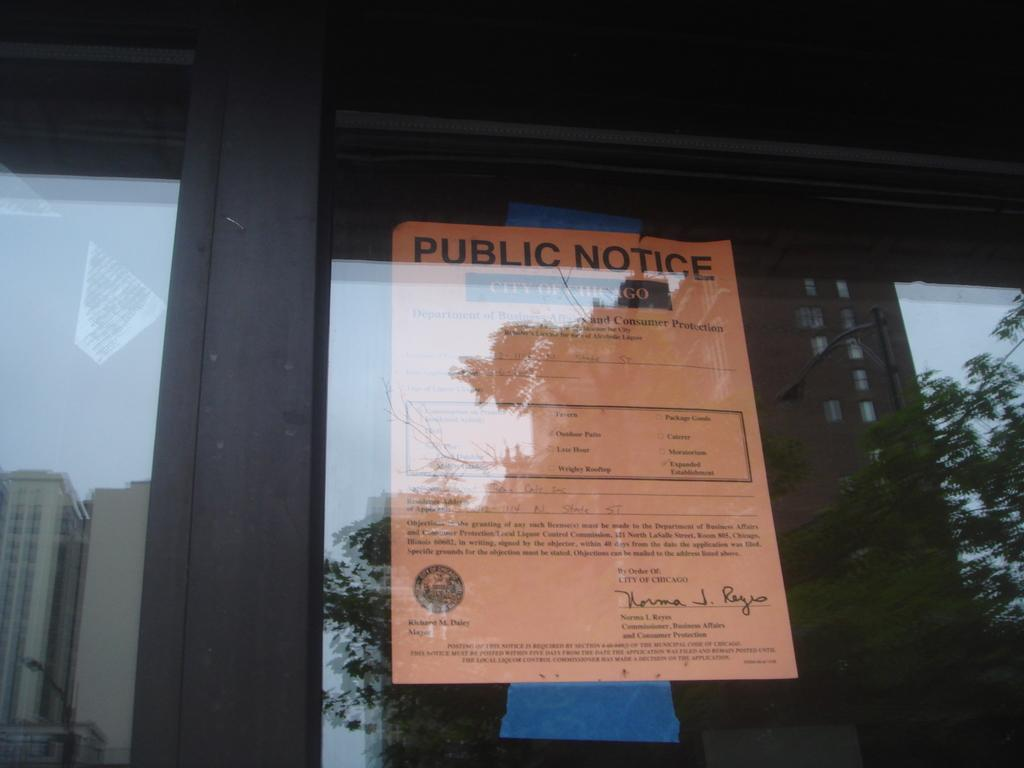What is attached to the transparent glass in the image? There is a paper stuck to a transparent glass in the image. What can be seen in the reflections on the transparent glass? There is a reflection of a building, trees, and the sky on the transparent glass. Where is the sink located in the image? There is no sink present in the image. What type of control is used to adjust the reflection of the street on the transparent glass? There is no control present in the image, and the reflection of the street is a natural occurrence due to the transparent glass. 